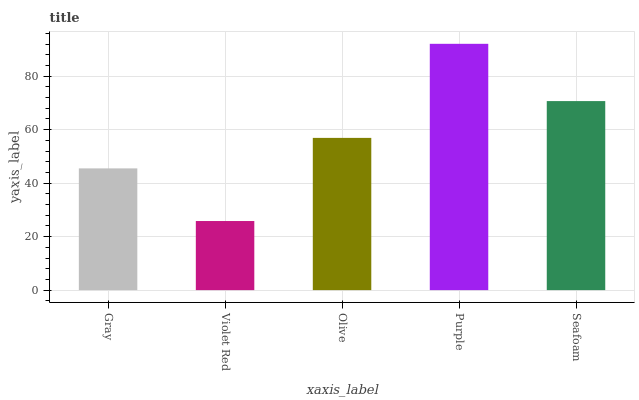Is Violet Red the minimum?
Answer yes or no. Yes. Is Purple the maximum?
Answer yes or no. Yes. Is Olive the minimum?
Answer yes or no. No. Is Olive the maximum?
Answer yes or no. No. Is Olive greater than Violet Red?
Answer yes or no. Yes. Is Violet Red less than Olive?
Answer yes or no. Yes. Is Violet Red greater than Olive?
Answer yes or no. No. Is Olive less than Violet Red?
Answer yes or no. No. Is Olive the high median?
Answer yes or no. Yes. Is Olive the low median?
Answer yes or no. Yes. Is Purple the high median?
Answer yes or no. No. Is Seafoam the low median?
Answer yes or no. No. 